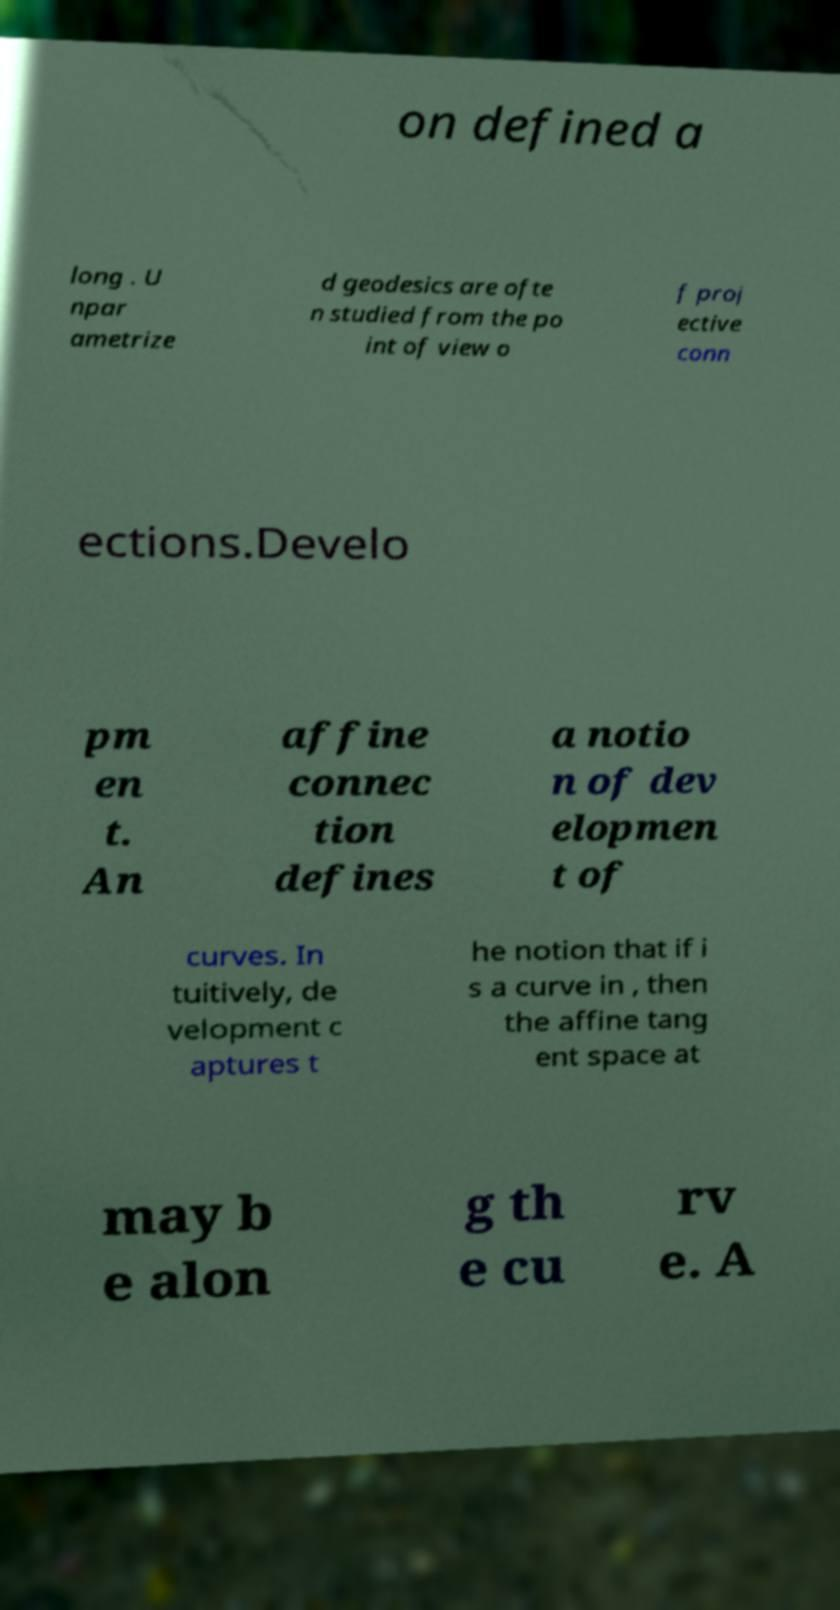For documentation purposes, I need the text within this image transcribed. Could you provide that? on defined a long . U npar ametrize d geodesics are ofte n studied from the po int of view o f proj ective conn ections.Develo pm en t. An affine connec tion defines a notio n of dev elopmen t of curves. In tuitively, de velopment c aptures t he notion that if i s a curve in , then the affine tang ent space at may b e alon g th e cu rv e. A 